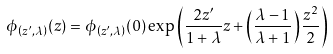<formula> <loc_0><loc_0><loc_500><loc_500>\phi _ { \left ( z ^ { \prime } , \lambda \right ) } ( z ) = \phi _ { \left ( z ^ { \prime } , \lambda \right ) } ( 0 ) \exp \left ( \frac { 2 z ^ { \prime } } { 1 + \lambda } z + \left ( \frac { \lambda - 1 } { \lambda + 1 } \right ) \frac { z ^ { 2 } } 2 \right )</formula> 